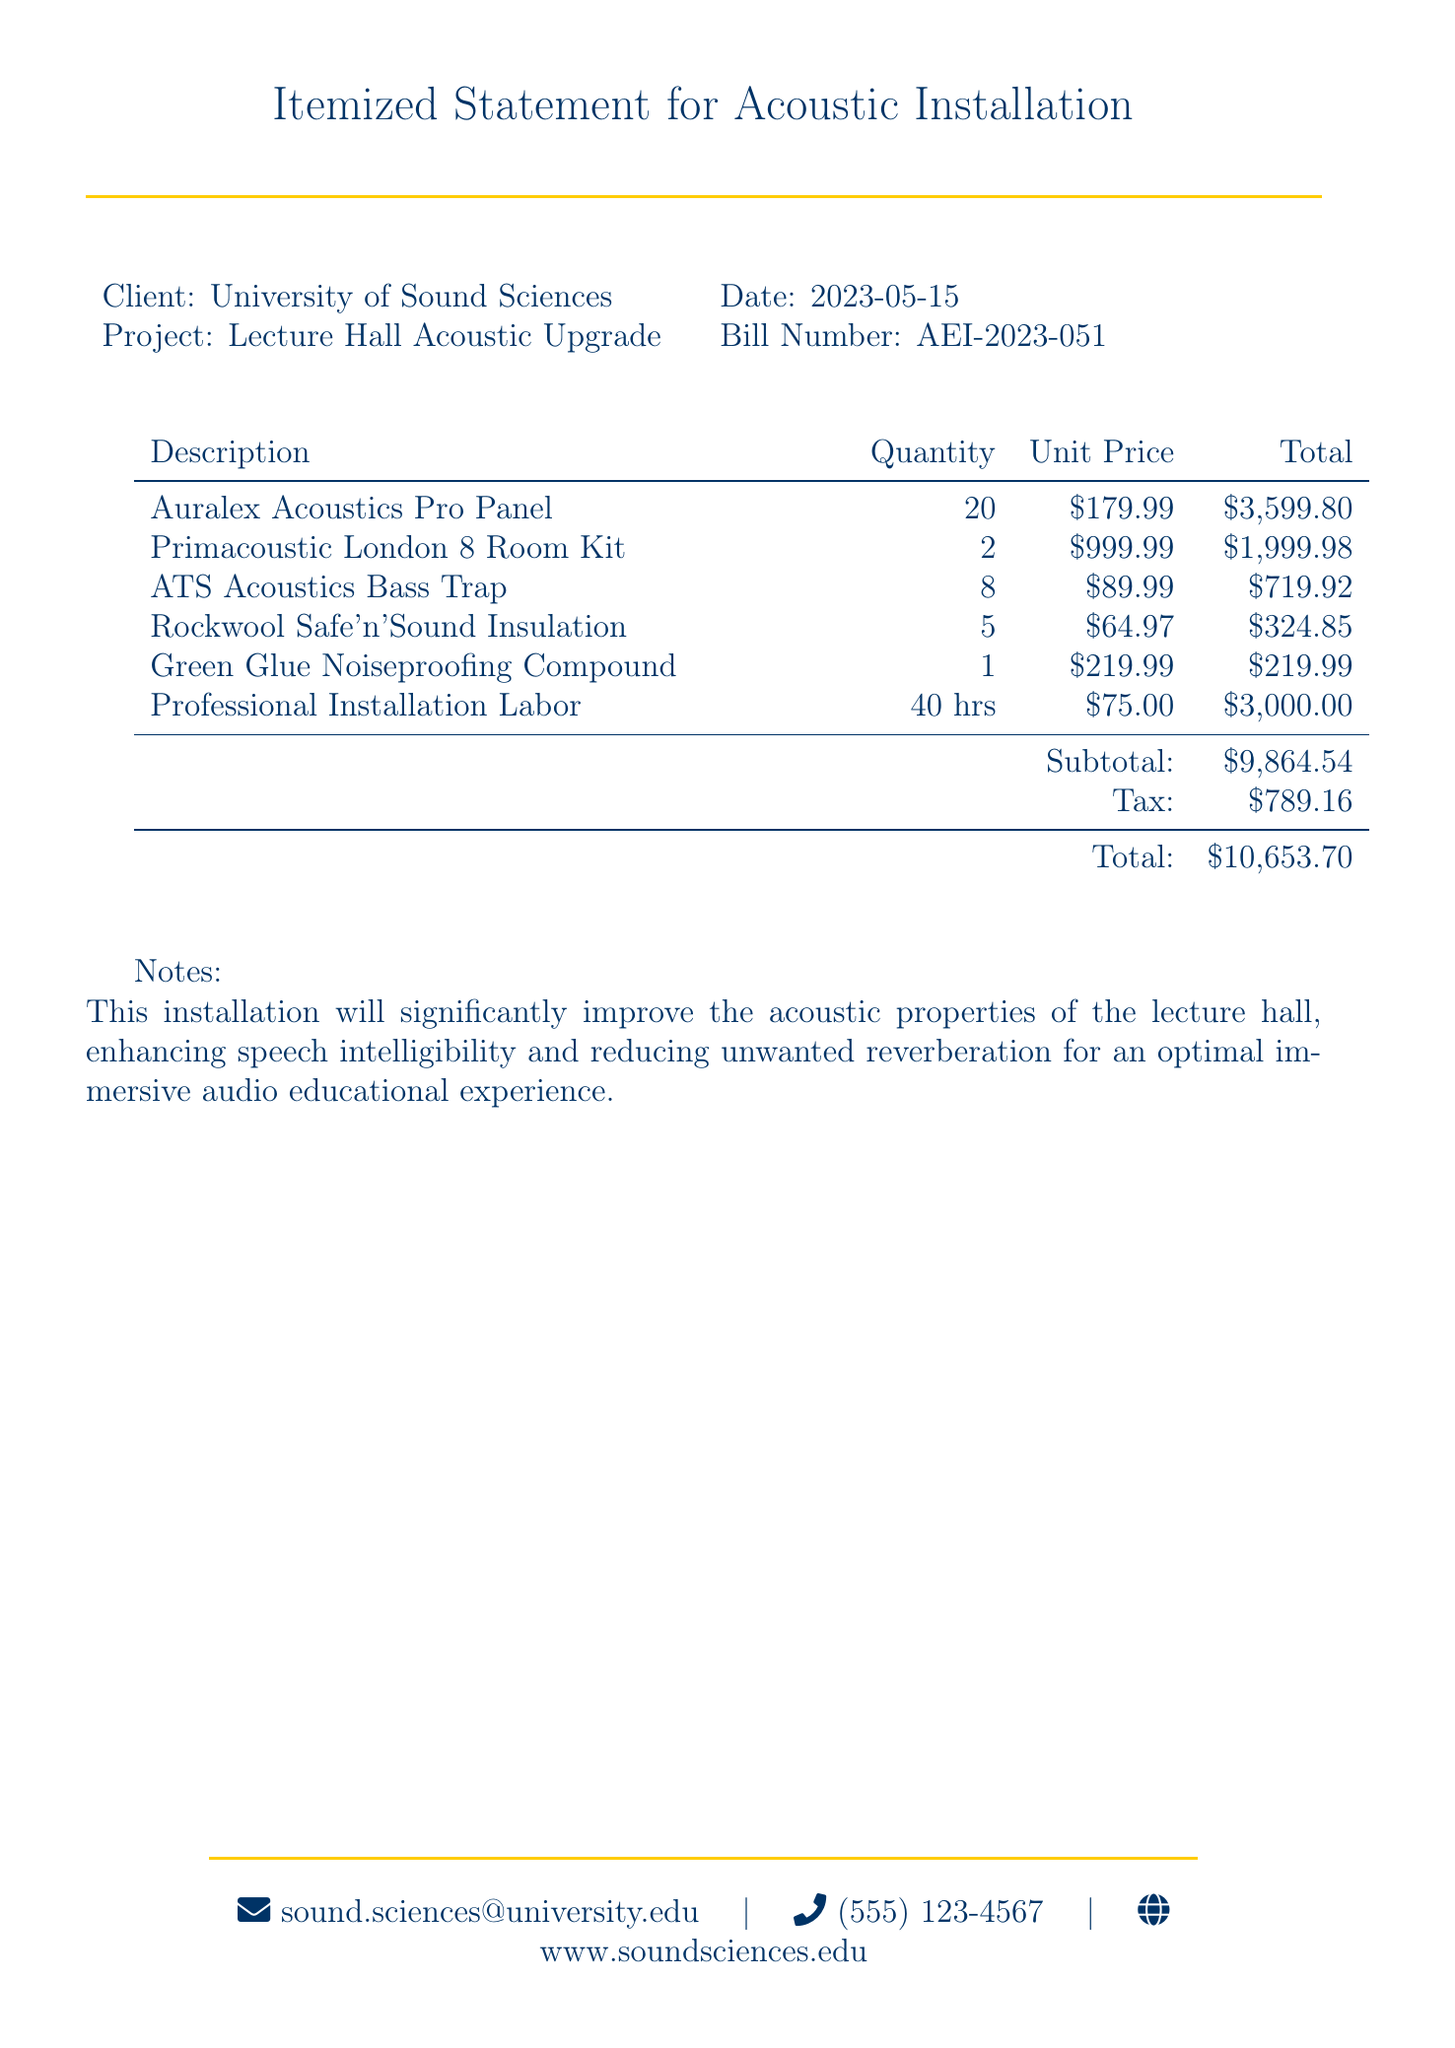What is the client name? The client name is clearly stated in the document, which is the University of Sound Sciences.
Answer: University of Sound Sciences What is the date of the bill? The date mentioned at the top of the document indicates when the bill was issued.
Answer: 2023-05-15 How many Auralex Acoustics Pro Panels were installed? The quantity of Auralex Acoustics Pro Panels is listed in the itemized statement.
Answer: 20 What is the subtotal amount? The subtotal is calculated as the sum of all total items before tax shown in the bill.
Answer: $9,864.54 What is the tax amount? The tax amount is specifically provided in the financial summary section of the document.
Answer: $789.16 What is the total amount due? The total amount combines the subtotal and tax to give the final bill amount.
Answer: $10,653.70 How many hours of labor were charged for professional installation? The document specifies the labor hours required for the installation of the acoustic materials.
Answer: 40 hrs Which compound was used for noiseproofing? The document lists the specific item used for noiseproofing in the installation.
Answer: Green Glue Noiseproofing Compound What does the notes section emphasize? The notes section provides the primary benefit of the installation in the lecture hall.
Answer: Improved acoustic properties 